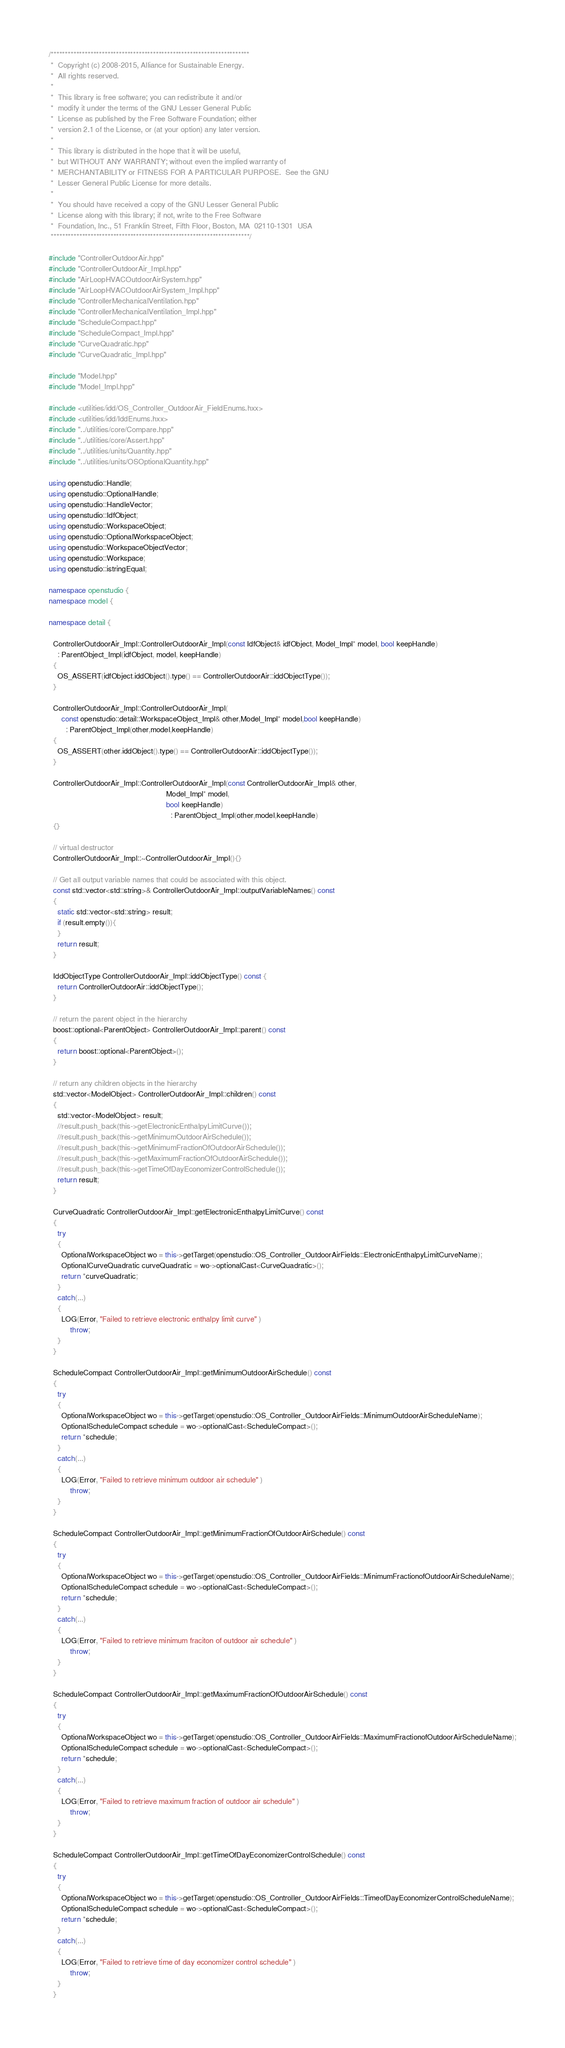<code> <loc_0><loc_0><loc_500><loc_500><_C++_>/**********************************************************************
 *  Copyright (c) 2008-2015, Alliance for Sustainable Energy.
 *  All rights reserved.
 *
 *  This library is free software; you can redistribute it and/or
 *  modify it under the terms of the GNU Lesser General Public
 *  License as published by the Free Software Foundation; either
 *  version 2.1 of the License, or (at your option) any later version.
 *
 *  This library is distributed in the hope that it will be useful,
 *  but WITHOUT ANY WARRANTY; without even the implied warranty of
 *  MERCHANTABILITY or FITNESS FOR A PARTICULAR PURPOSE.  See the GNU
 *  Lesser General Public License for more details.
 *
 *  You should have received a copy of the GNU Lesser General Public
 *  License along with this library; if not, write to the Free Software
 *  Foundation, Inc., 51 Franklin Street, Fifth Floor, Boston, MA  02110-1301  USA
 **********************************************************************/

#include "ControllerOutdoorAir.hpp"
#include "ControllerOutdoorAir_Impl.hpp"
#include "AirLoopHVACOutdoorAirSystem.hpp"
#include "AirLoopHVACOutdoorAirSystem_Impl.hpp"
#include "ControllerMechanicalVentilation.hpp"
#include "ControllerMechanicalVentilation_Impl.hpp"
#include "ScheduleCompact.hpp"
#include "ScheduleCompact_Impl.hpp"
#include "CurveQuadratic.hpp"
#include "CurveQuadratic_Impl.hpp"

#include "Model.hpp"
#include "Model_Impl.hpp"

#include <utilities/idd/OS_Controller_OutdoorAir_FieldEnums.hxx>
#include <utilities/idd/IddEnums.hxx>
#include "../utilities/core/Compare.hpp"
#include "../utilities/core/Assert.hpp"
#include "../utilities/units/Quantity.hpp"
#include "../utilities/units/OSOptionalQuantity.hpp"

using openstudio::Handle;
using openstudio::OptionalHandle;
using openstudio::HandleVector;
using openstudio::IdfObject;
using openstudio::WorkspaceObject;
using openstudio::OptionalWorkspaceObject;
using openstudio::WorkspaceObjectVector;
using openstudio::Workspace;
using openstudio::istringEqual;

namespace openstudio {
namespace model {

namespace detail {

  ControllerOutdoorAir_Impl::ControllerOutdoorAir_Impl(const IdfObject& idfObject, Model_Impl* model, bool keepHandle)
    : ParentObject_Impl(idfObject, model, keepHandle)
  {
    OS_ASSERT(idfObject.iddObject().type() == ControllerOutdoorAir::iddObjectType());
  }

  ControllerOutdoorAir_Impl::ControllerOutdoorAir_Impl(
      const openstudio::detail::WorkspaceObject_Impl& other,Model_Impl* model,bool keepHandle)
        : ParentObject_Impl(other,model,keepHandle)
  {
    OS_ASSERT(other.iddObject().type() == ControllerOutdoorAir::iddObjectType());
  }

  ControllerOutdoorAir_Impl::ControllerOutdoorAir_Impl(const ControllerOutdoorAir_Impl& other,
                                                       Model_Impl* model,
                                                       bool keepHandle)
                                                         : ParentObject_Impl(other,model,keepHandle)
  {}

  // virtual destructor
  ControllerOutdoorAir_Impl::~ControllerOutdoorAir_Impl(){}

  // Get all output variable names that could be associated with this object.
  const std::vector<std::string>& ControllerOutdoorAir_Impl::outputVariableNames() const
  {
    static std::vector<std::string> result;
    if (result.empty()){
    }
    return result;
  }

  IddObjectType ControllerOutdoorAir_Impl::iddObjectType() const {
    return ControllerOutdoorAir::iddObjectType();
  }

  // return the parent object in the hierarchy
  boost::optional<ParentObject> ControllerOutdoorAir_Impl::parent() const
  {
    return boost::optional<ParentObject>();
  }

  // return any children objects in the hierarchy
  std::vector<ModelObject> ControllerOutdoorAir_Impl::children() const
  {
    std::vector<ModelObject> result;
    //result.push_back(this->getElectronicEnthalpyLimitCurve());
    //result.push_back(this->getMinimumOutdoorAirSchedule());
    //result.push_back(this->getMinimumFractionOfOutdoorAirSchedule());
    //result.push_back(this->getMaximumFractionOfOutdoorAirSchedule());
    //result.push_back(this->getTimeOfDayEconomizerControlSchedule());
    return result;
  }

  CurveQuadratic ControllerOutdoorAir_Impl::getElectronicEnthalpyLimitCurve() const
  {
    try
    {
      OptionalWorkspaceObject wo = this->getTarget(openstudio::OS_Controller_OutdoorAirFields::ElectronicEnthalpyLimitCurveName);
      OptionalCurveQuadratic curveQuadratic = wo->optionalCast<CurveQuadratic>();
      return *curveQuadratic;
    }
    catch(...)
    {
      LOG(Error, "Failed to retrieve electronic enthalpy limit curve" )
          throw;
    }
  }

  ScheduleCompact ControllerOutdoorAir_Impl::getMinimumOutdoorAirSchedule() const
  {
    try
    {
      OptionalWorkspaceObject wo = this->getTarget(openstudio::OS_Controller_OutdoorAirFields::MinimumOutdoorAirScheduleName);
      OptionalScheduleCompact schedule = wo->optionalCast<ScheduleCompact>();
      return *schedule;
    }
    catch(...)
    {
      LOG(Error, "Failed to retrieve minimum outdoor air schedule" )
          throw;
    }
  }

  ScheduleCompact ControllerOutdoorAir_Impl::getMinimumFractionOfOutdoorAirSchedule() const
  {
    try
    {
      OptionalWorkspaceObject wo = this->getTarget(openstudio::OS_Controller_OutdoorAirFields::MinimumFractionofOutdoorAirScheduleName);
      OptionalScheduleCompact schedule = wo->optionalCast<ScheduleCompact>();
      return *schedule;
    }
    catch(...)
    {
      LOG(Error, "Failed to retrieve minimum fraciton of outdoor air schedule" )
          throw;
    }
  }

  ScheduleCompact ControllerOutdoorAir_Impl::getMaximumFractionOfOutdoorAirSchedule() const
  {
    try
    {
      OptionalWorkspaceObject wo = this->getTarget(openstudio::OS_Controller_OutdoorAirFields::MaximumFractionofOutdoorAirScheduleName);
      OptionalScheduleCompact schedule = wo->optionalCast<ScheduleCompact>();
      return *schedule;
    }
    catch(...)
    {
      LOG(Error, "Failed to retrieve maximum fraction of outdoor air schedule" )
          throw;
    }
  }

  ScheduleCompact ControllerOutdoorAir_Impl::getTimeOfDayEconomizerControlSchedule() const
  {
    try
    {
      OptionalWorkspaceObject wo = this->getTarget(openstudio::OS_Controller_OutdoorAirFields::TimeofDayEconomizerControlScheduleName);
      OptionalScheduleCompact schedule = wo->optionalCast<ScheduleCompact>();
      return *schedule;
    }
    catch(...)
    {
      LOG(Error, "Failed to retrieve time of day economizer control schedule" )
          throw;
    }
  }
</code> 